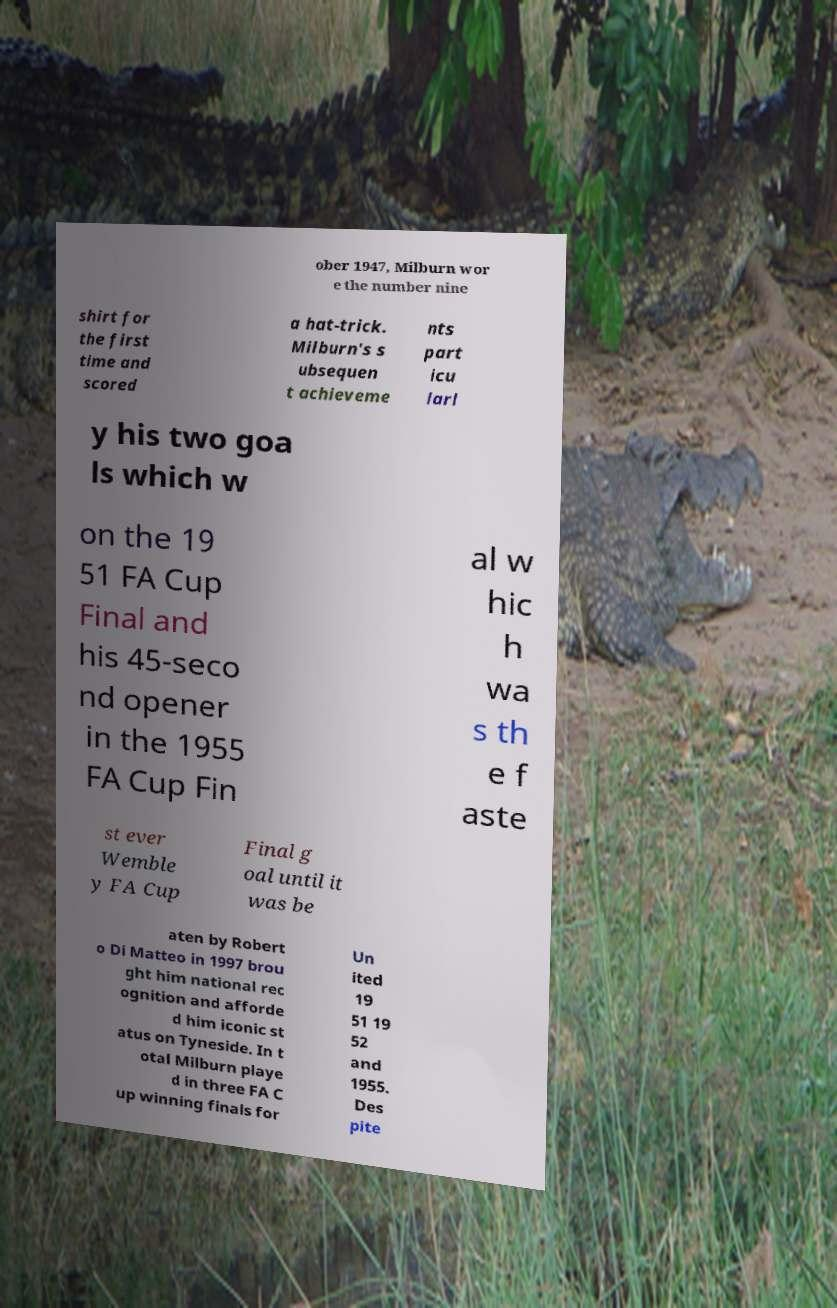Can you accurately transcribe the text from the provided image for me? ober 1947, Milburn wor e the number nine shirt for the first time and scored a hat-trick. Milburn's s ubsequen t achieveme nts part icu larl y his two goa ls which w on the 19 51 FA Cup Final and his 45-seco nd opener in the 1955 FA Cup Fin al w hic h wa s th e f aste st ever Wemble y FA Cup Final g oal until it was be aten by Robert o Di Matteo in 1997 brou ght him national rec ognition and afforde d him iconic st atus on Tyneside. In t otal Milburn playe d in three FA C up winning finals for Un ited 19 51 19 52 and 1955. Des pite 